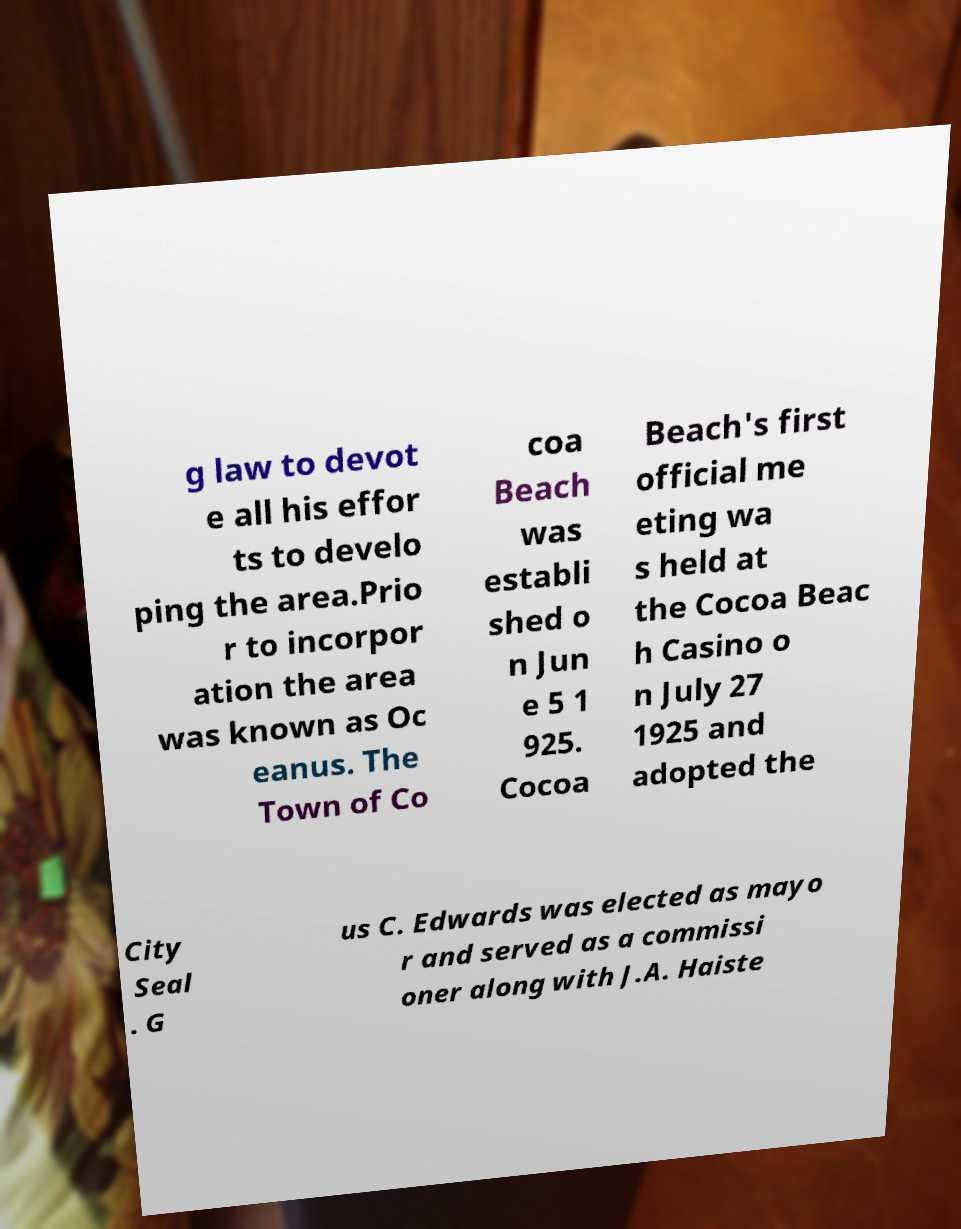Can you read and provide the text displayed in the image?This photo seems to have some interesting text. Can you extract and type it out for me? g law to devot e all his effor ts to develo ping the area.Prio r to incorpor ation the area was known as Oc eanus. The Town of Co coa Beach was establi shed o n Jun e 5 1 925. Cocoa Beach's first official me eting wa s held at the Cocoa Beac h Casino o n July 27 1925 and adopted the City Seal . G us C. Edwards was elected as mayo r and served as a commissi oner along with J.A. Haiste 